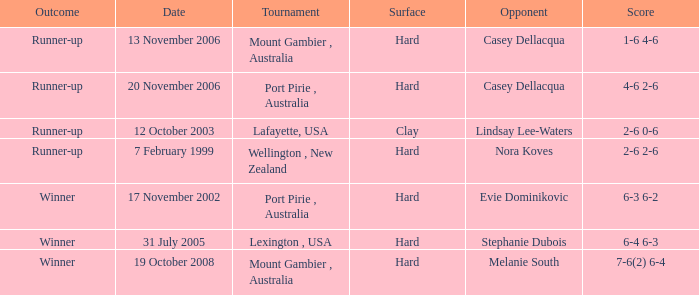When is a rival competing against evie dominikovic? 17 November 2002. 